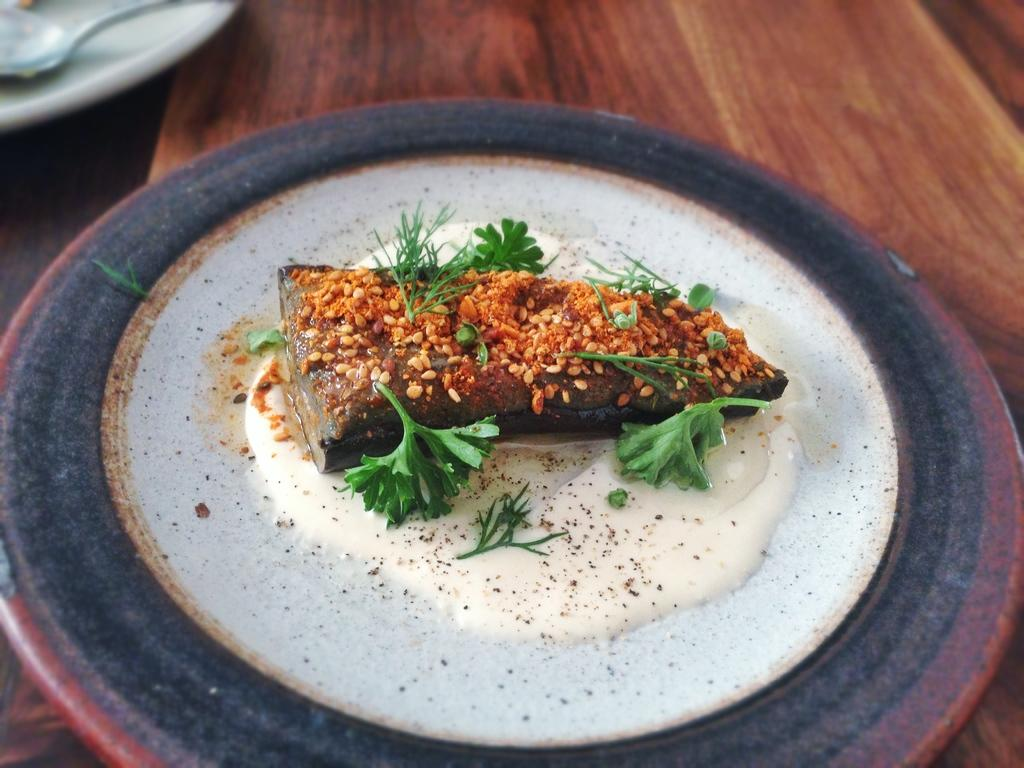What object is present on the table in the image? There is a plate on the table in the image. What is the purpose of the plate in the image? The plate is used to hold food. What can be found on the plate in the image? There is food on the plate. What type of yak can be seen using a hammer to answer questions in the image? There is no yak or hammer present in the image, and no one is answering questions. 